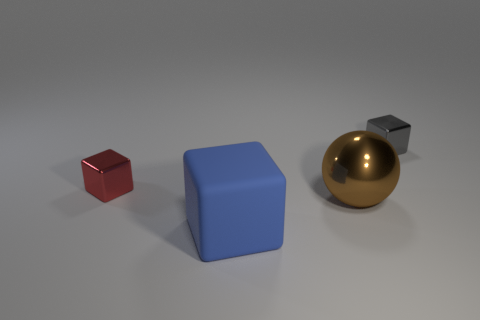Is there a large brown shiny thing to the right of the red cube that is behind the large ball?
Provide a short and direct response. Yes. What number of objects are small metallic objects that are to the right of the brown metal ball or blue matte things?
Offer a very short reply. 2. How many big blue matte things are there?
Provide a short and direct response. 1. There is a tiny thing that is the same material as the gray block; what shape is it?
Ensure brevity in your answer.  Cube. How big is the shiny object that is behind the tiny cube to the left of the brown ball?
Your response must be concise. Small. How many objects are small blocks that are behind the tiny red metal thing or things that are behind the big rubber cube?
Give a very brief answer. 3. Is the number of big rubber balls less than the number of big blue cubes?
Offer a terse response. Yes. How many objects are matte objects or big things?
Keep it short and to the point. 2. Do the red thing and the blue rubber object have the same shape?
Give a very brief answer. Yes. Are there any other things that are made of the same material as the blue object?
Offer a very short reply. No. 